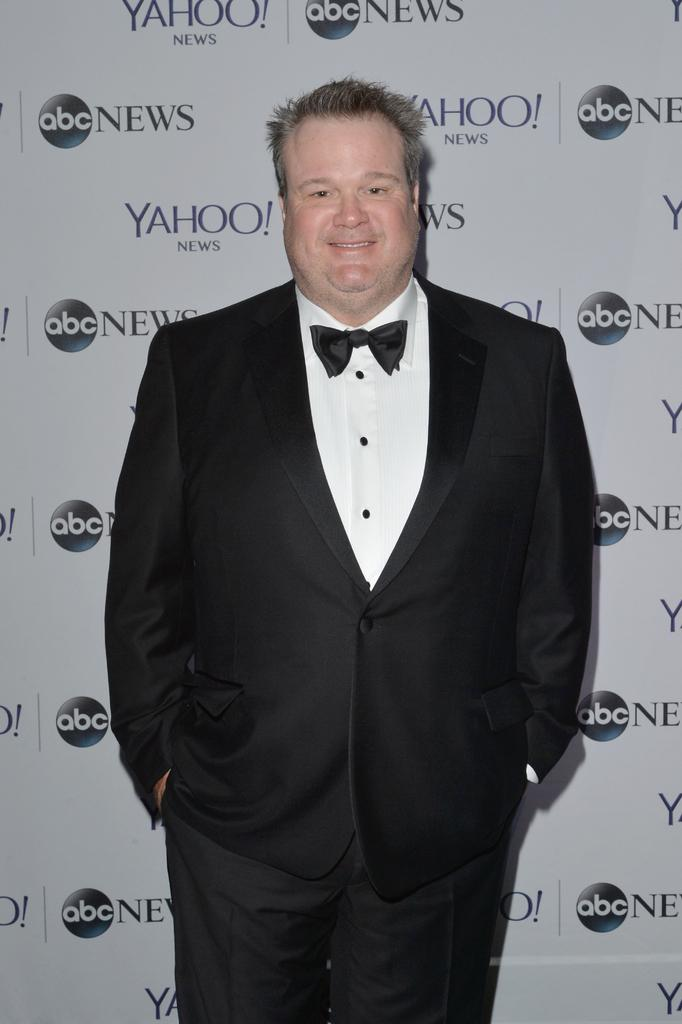What is the person in the image wearing? The person is wearing a black suit. What can be seen in the background of the image? There is a wall and logos in the background of the image. Can you describe the setting of the image? The image may have been taken in a hall. What type of corn is being grown on the person's mind in the image? There is no corn or reference to a person's mind in the image; it features a person wearing a black suit in a possible hall setting. 